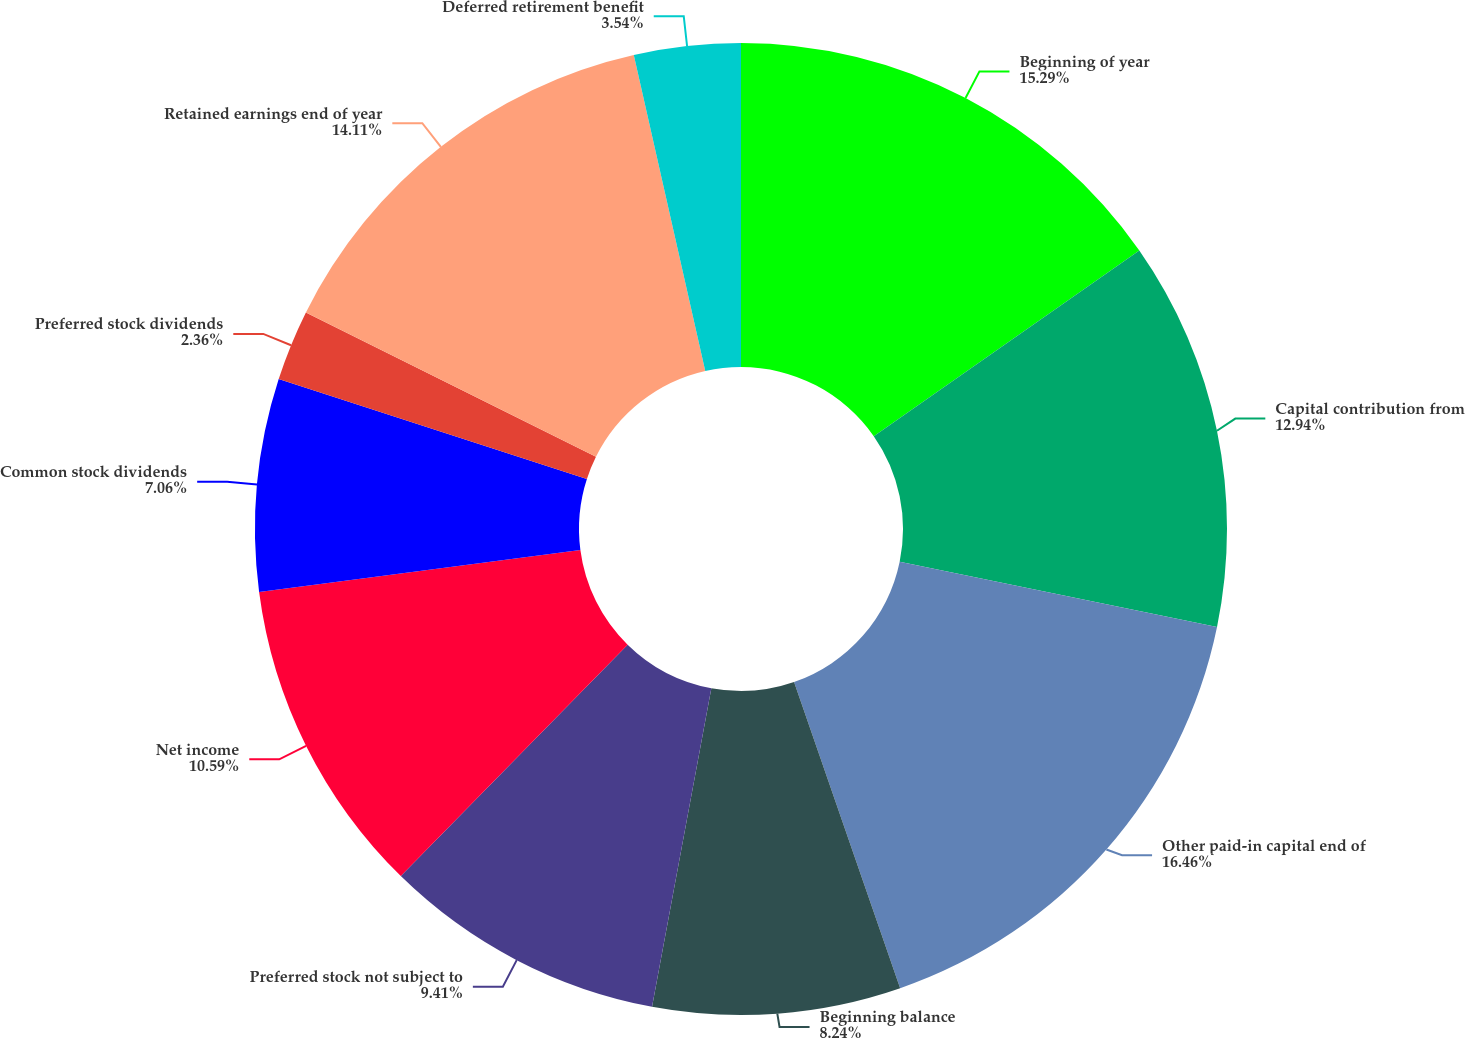Convert chart. <chart><loc_0><loc_0><loc_500><loc_500><pie_chart><fcel>Beginning of year<fcel>Capital contribution from<fcel>Other paid-in capital end of<fcel>Beginning balance<fcel>Preferred stock not subject to<fcel>Net income<fcel>Common stock dividends<fcel>Preferred stock dividends<fcel>Retained earnings end of year<fcel>Deferred retirement benefit<nl><fcel>15.29%<fcel>12.94%<fcel>16.46%<fcel>8.24%<fcel>9.41%<fcel>10.59%<fcel>7.06%<fcel>2.36%<fcel>14.11%<fcel>3.54%<nl></chart> 